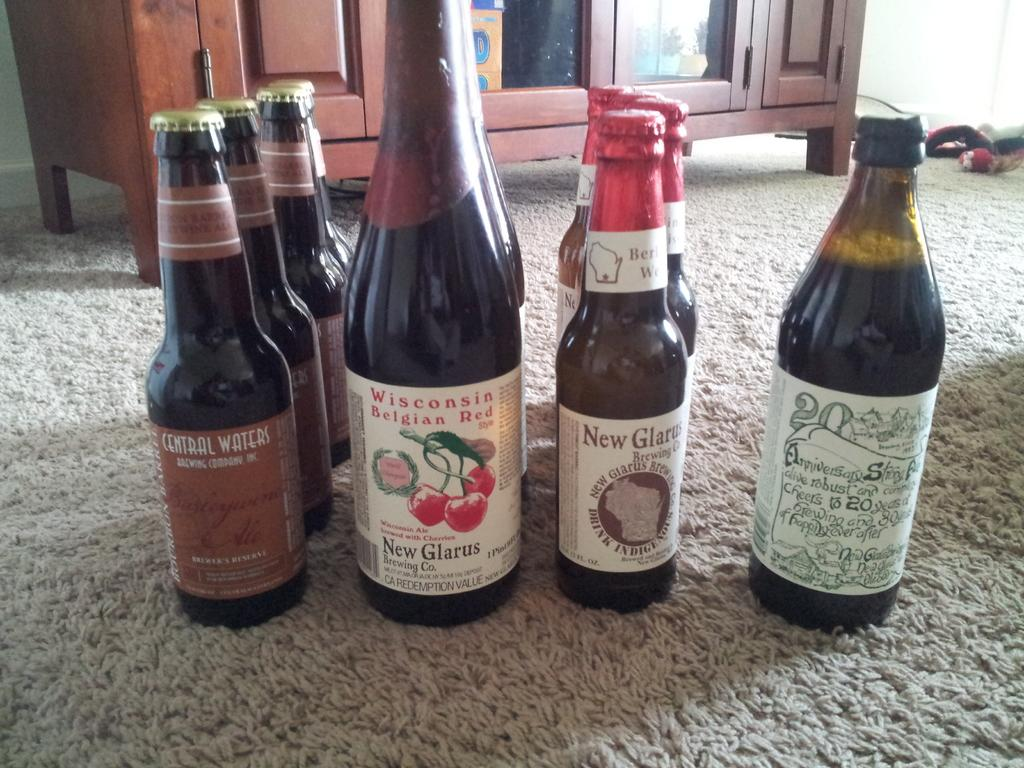What objects are located in the middle of the image? There are bottles in the middle of the image. Where are the bottles placed? The bottles are on the floor. What structure is visible behind the bottles? There is a cupboard behind the bottles. How does the respect for the railway manifest in the image? There is no reference to a railway or respect in the image, so it's not possible to determine how respect for the railway might be manifested. 